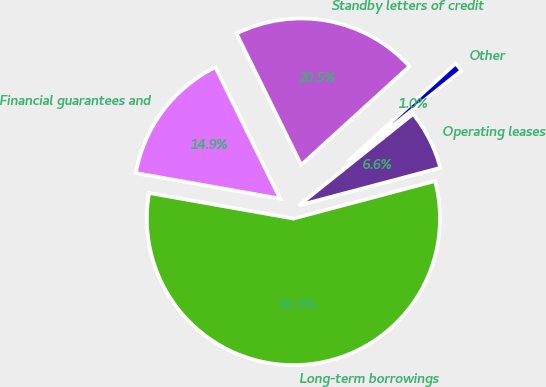Convert chart to OTSL. <chart><loc_0><loc_0><loc_500><loc_500><pie_chart><fcel>Long-term borrowings<fcel>Operating leases<fcel>Other<fcel>Standby letters of credit<fcel>Financial guarantees and<nl><fcel>56.92%<fcel>6.61%<fcel>1.02%<fcel>20.52%<fcel>14.93%<nl></chart> 